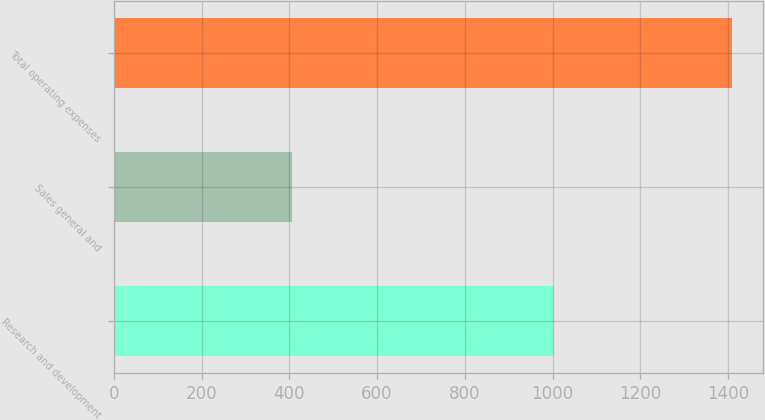<chart> <loc_0><loc_0><loc_500><loc_500><bar_chart><fcel>Research and development<fcel>Sales general and<fcel>Total operating expenses<nl><fcel>1002.6<fcel>405.6<fcel>1408.2<nl></chart> 